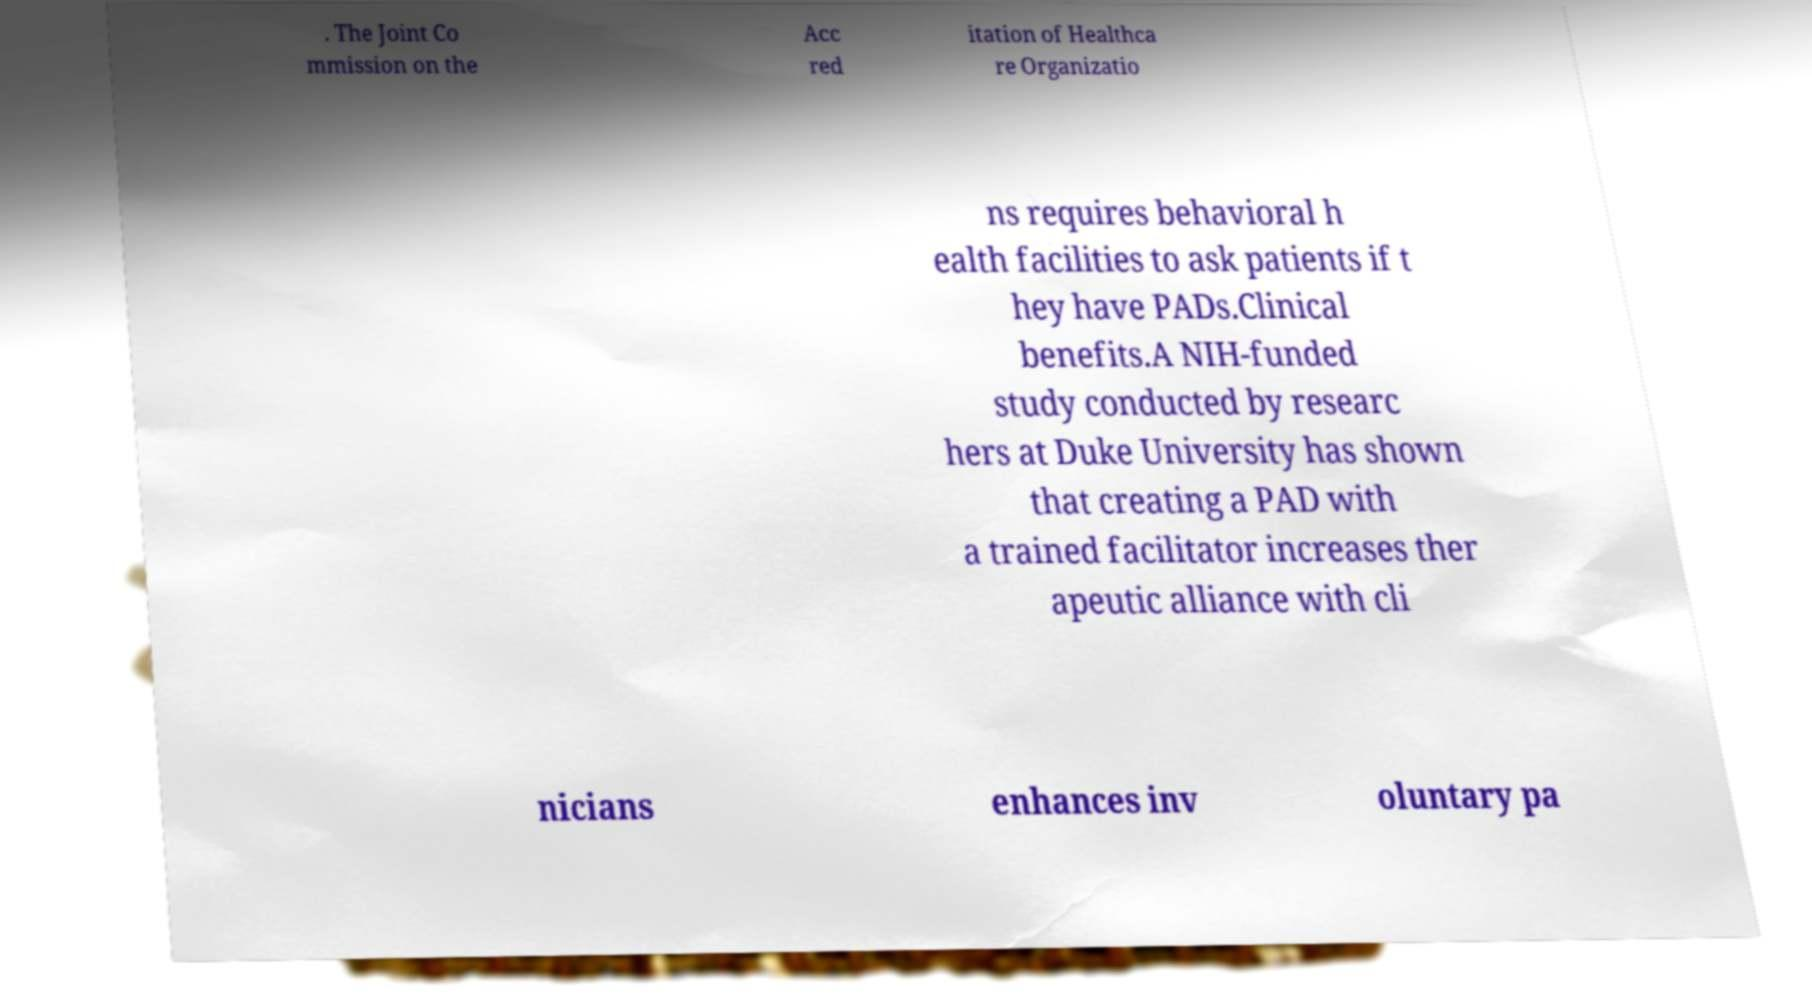I need the written content from this picture converted into text. Can you do that? . The Joint Co mmission on the Acc red itation of Healthca re Organizatio ns requires behavioral h ealth facilities to ask patients if t hey have PADs.Clinical benefits.A NIH-funded study conducted by researc hers at Duke University has shown that creating a PAD with a trained facilitator increases ther apeutic alliance with cli nicians enhances inv oluntary pa 